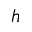Convert formula to latex. <formula><loc_0><loc_0><loc_500><loc_500>h</formula> 